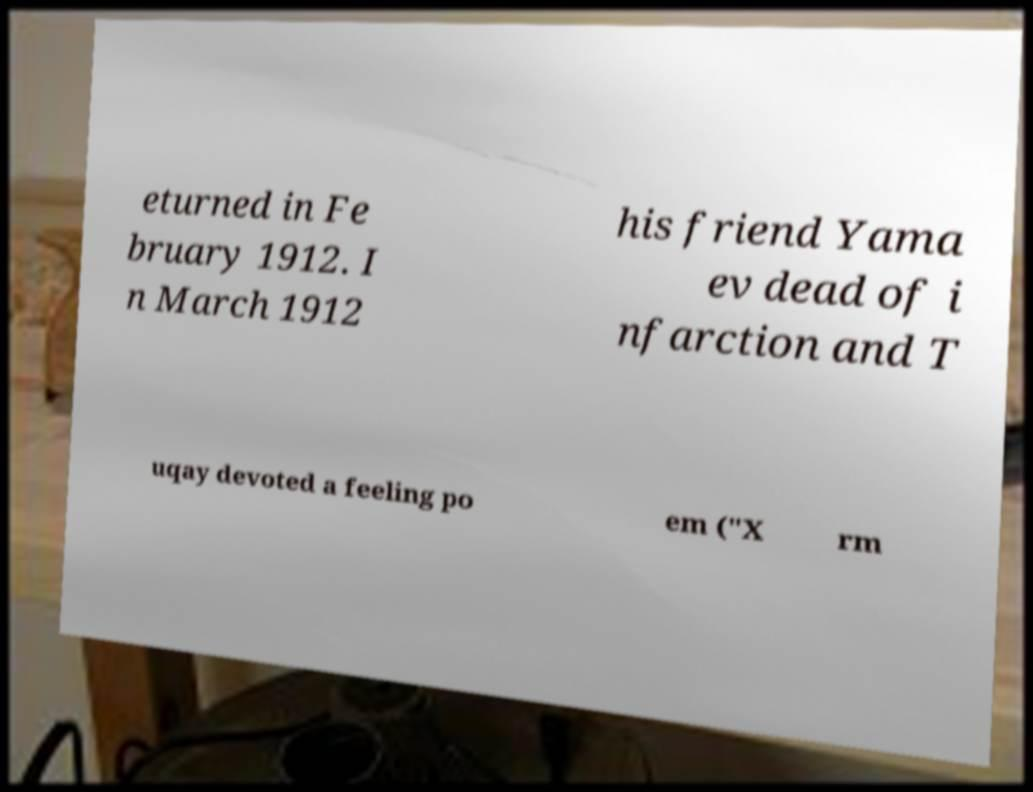I need the written content from this picture converted into text. Can you do that? eturned in Fe bruary 1912. I n March 1912 his friend Yama ev dead of i nfarction and T uqay devoted a feeling po em ("X rm 